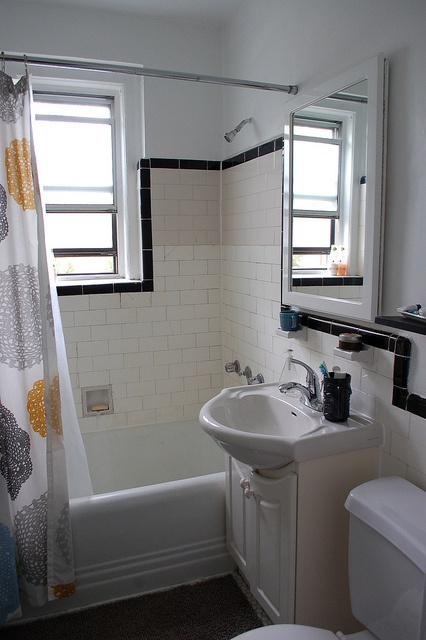Describe the objects in this image and their specific colors. I can see sink in gray, darkgray, and black tones, toilet in gray tones, toilet in gray and black tones, toothbrush in gray, blue, darkblue, and darkgray tones, and toothbrush in gray, darkgray, and black tones in this image. 